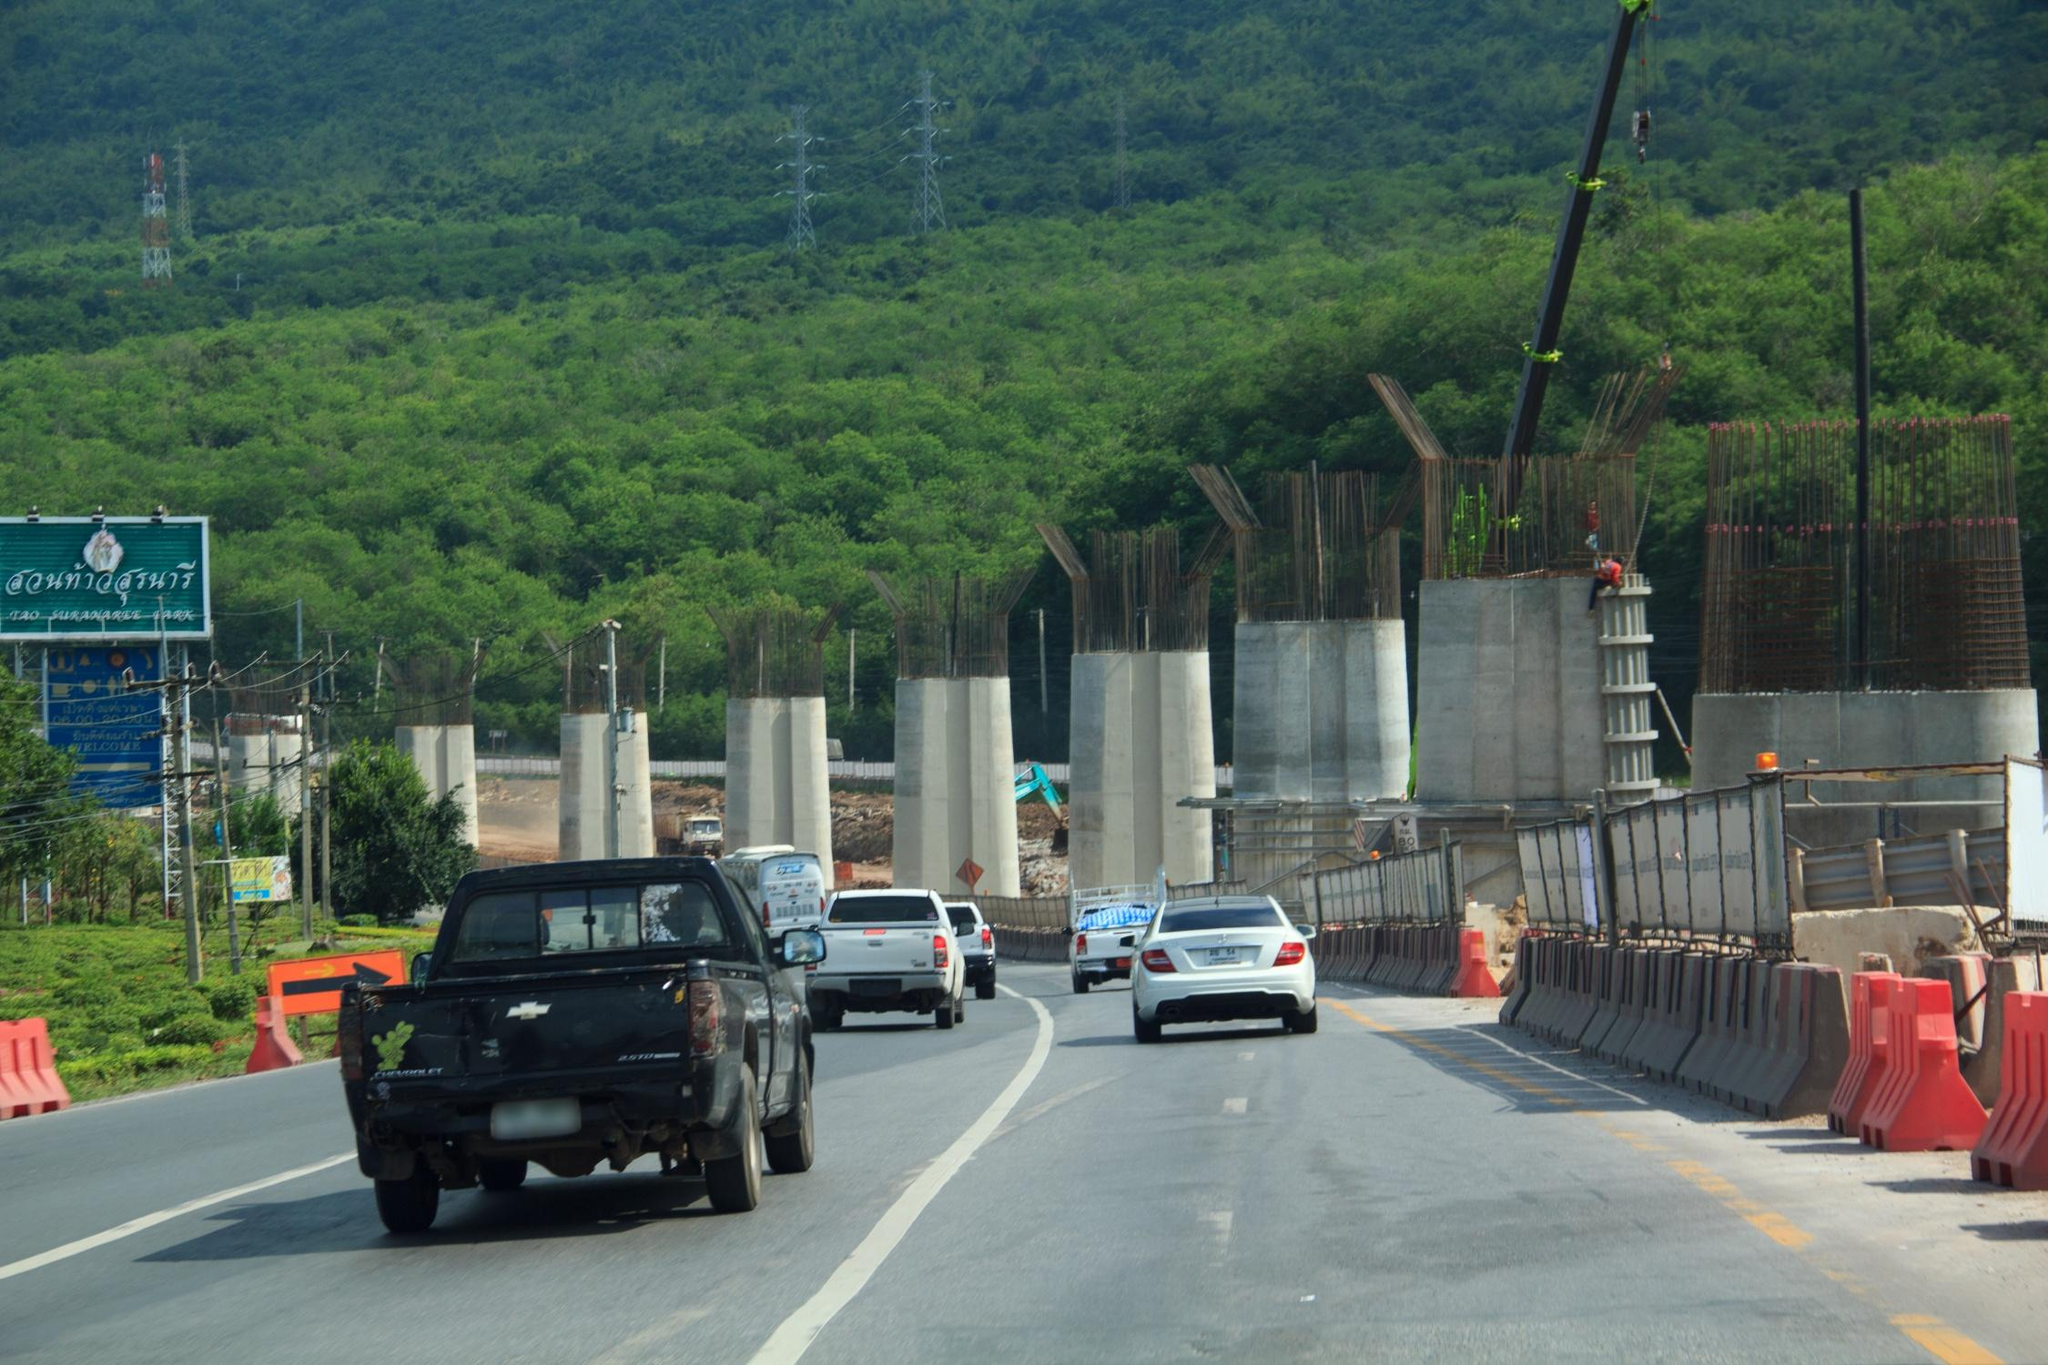Imagine this construction site 50 years into the future. How might it look? In 50 years, this once-busy construction site may transform into a bustling and well-integrated part of a major transportation network. The highway would be fully completed, with smooth asphalt lanes handling a constant flow of vehicles. Advanced technological innovations, such as autonomous vehicles, could dominate the traffic, seamlessly traveling along the route with high efficiency and minimal congestion. Smart traffic management systems might be in place, adjusting traffic flow in real-time to optimize travel times. The surrounding greenery would have recovered, with landscaping efforts ensuring a harmonious blend between the infrastructure and natural environment. Additionally, support facilities like rest stops, electric vehicle charging stations, and perhaps even eco-friendly overpasses could enhance the travel experience while maintaining environmental sustainability. 